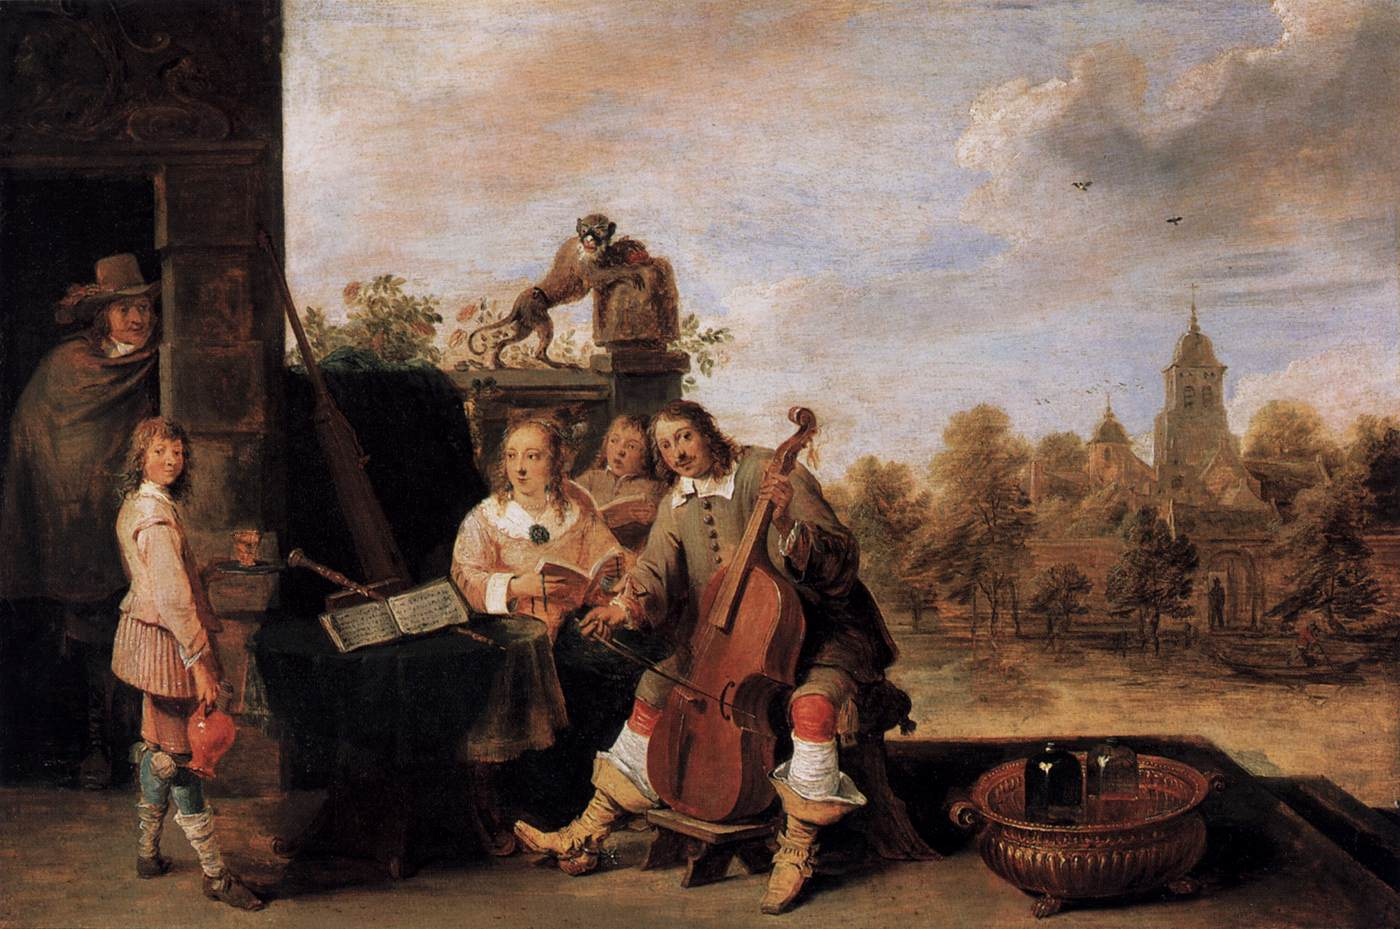Can you describe the main features of this image for me? The image is a classical painting that depicts a group of figures in a pastoral setting. At the center, there is a man playing a cello, his facial expression conveying focus and emotion. To his left, a woman holding a piece of sheet music sings, while a boy intently reading the music stands further to the left. In the background, lies a church nestled among the trees, suggesting that this scene might be occurring at a community event or near a village. The sky is filled with soft clouds, creating a sense of timelessness and tranquility typical of landscape scenes in classical art. The details in clothing and facial expressions add to the narrative, hinting at the leisure and cultural activities of the period being depicted. 